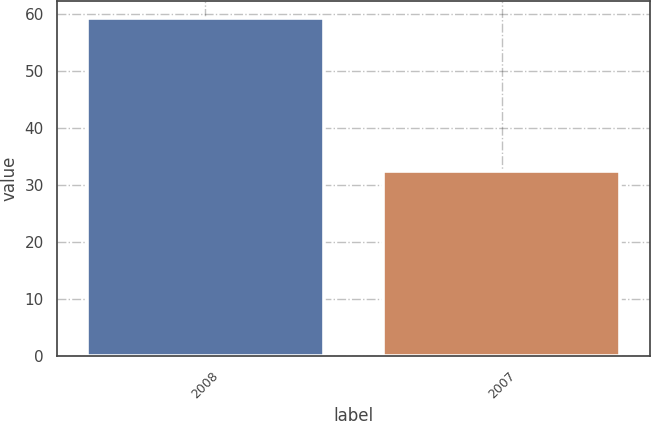Convert chart to OTSL. <chart><loc_0><loc_0><loc_500><loc_500><bar_chart><fcel>2008<fcel>2007<nl><fcel>59.4<fcel>32.5<nl></chart> 